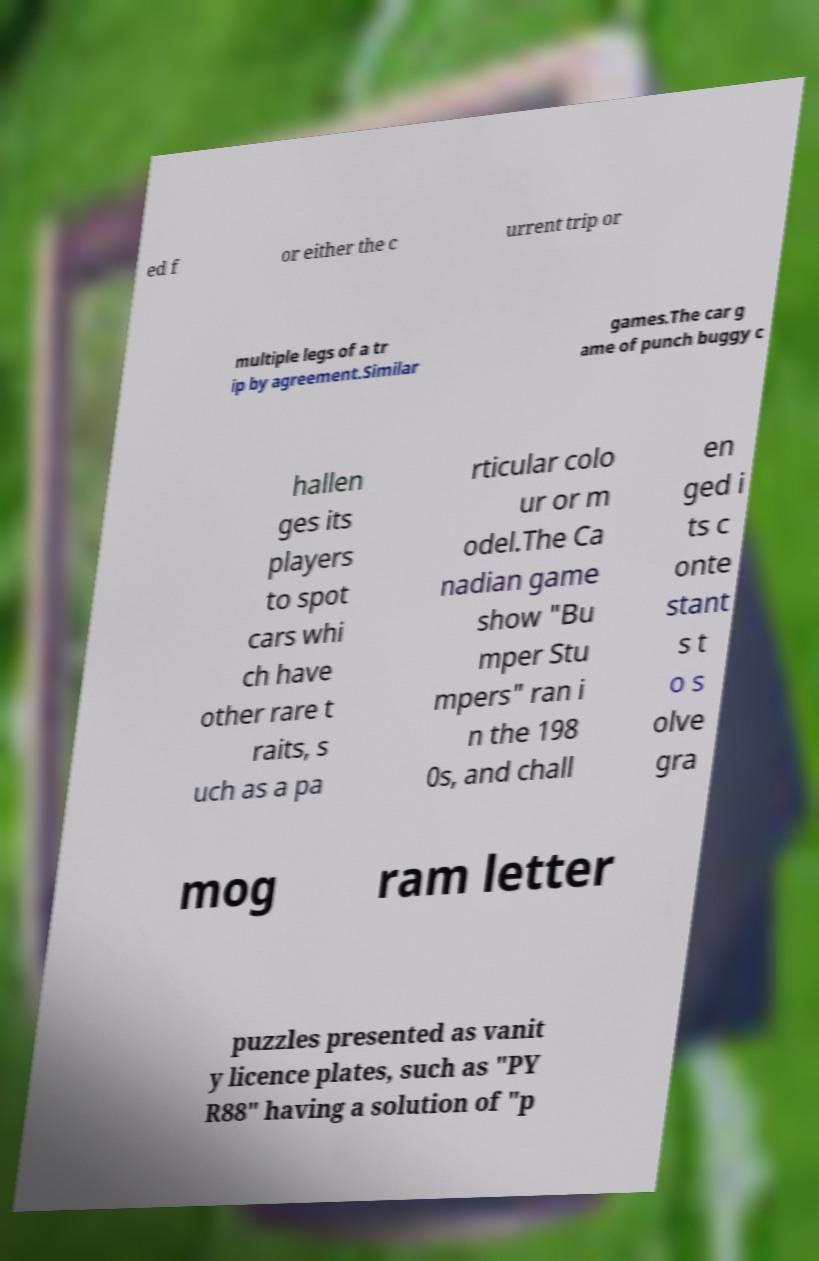I need the written content from this picture converted into text. Can you do that? ed f or either the c urrent trip or multiple legs of a tr ip by agreement.Similar games.The car g ame of punch buggy c hallen ges its players to spot cars whi ch have other rare t raits, s uch as a pa rticular colo ur or m odel.The Ca nadian game show "Bu mper Stu mpers" ran i n the 198 0s, and chall en ged i ts c onte stant s t o s olve gra mog ram letter puzzles presented as vanit y licence plates, such as "PY R88" having a solution of "p 